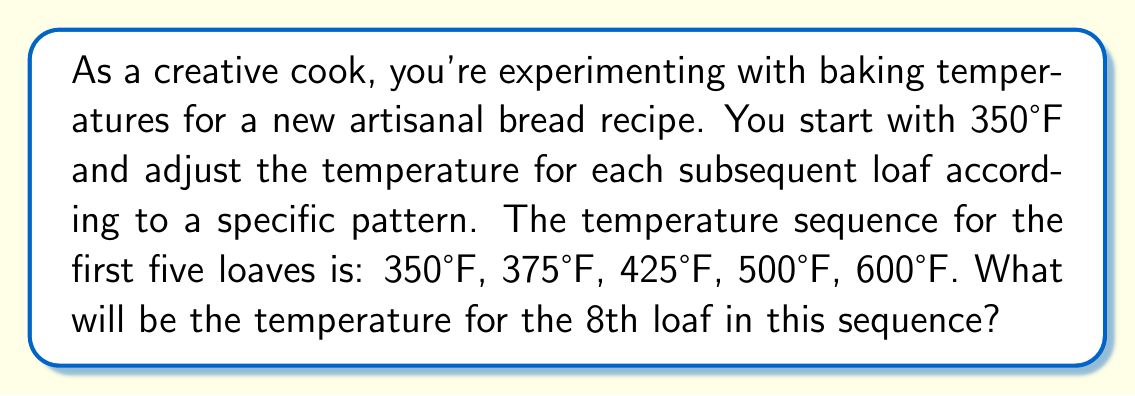Show me your answer to this math problem. Let's approach this step-by-step:

1) First, let's look at the differences between consecutive temperatures:
   350 to 375: +25
   375 to 425: +50
   425 to 500: +75
   500 to 600: +100

2) We can see that the temperature increase itself is increasing by 25 each time:
   25, 50, 75, 100

3) This forms an arithmetic sequence with a common difference of 25.

4) We can express the nth temperature increase as:
   $$a_n = 25n$$
   where $n$ starts at 1 for the first increase.

5) To find the temperature of the nth loaf, we need to sum all previous increases and add to the initial temperature:
   $$T_n = 350 + \sum_{i=1}^{n-1} 25i$$

6) This sum can be calculated using the formula for the sum of an arithmetic sequence:
   $$\sum_{i=1}^{n-1} i = \frac{n(n-1)}{2}$$

7) Therefore, our temperature formula becomes:
   $$T_n = 350 + 25 \cdot \frac{(n-1)n}{2}$$

8) For the 8th loaf, n = 8:
   $$T_8 = 350 + 25 \cdot \frac{(8-1)8}{2}$$
   $$= 350 + 25 \cdot \frac{56}{2}$$
   $$= 350 + 25 \cdot 28$$
   $$= 350 + 700 = 1050$$

Thus, the temperature for the 8th loaf will be 1050°F.
Answer: 1050°F 